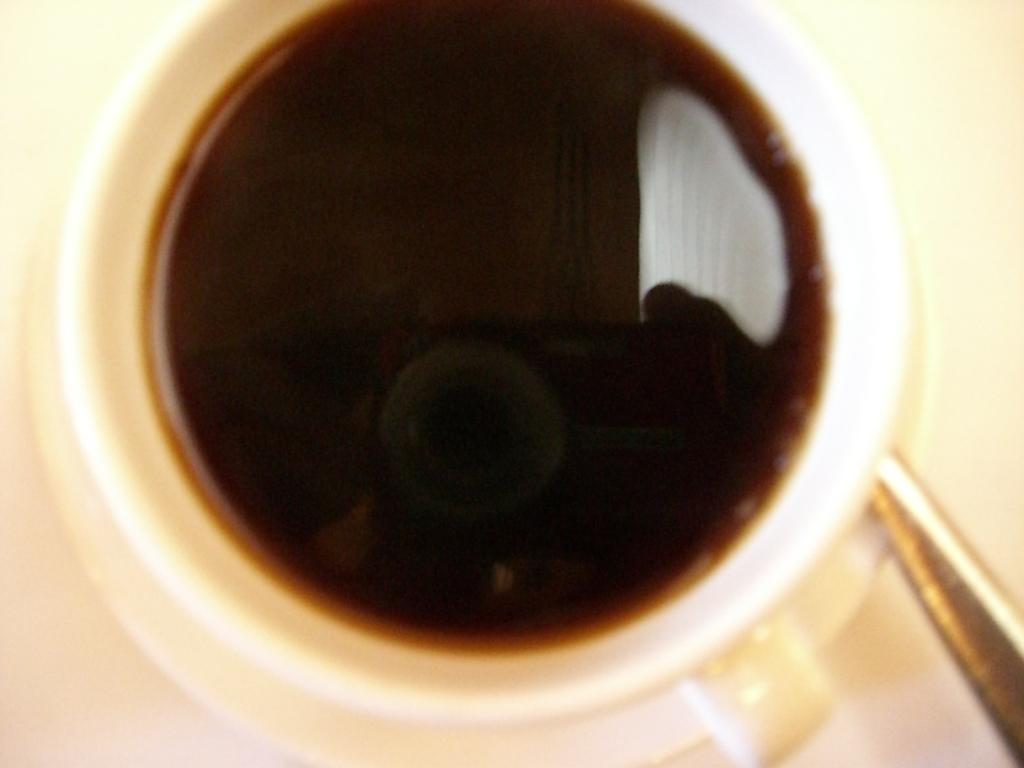What object is present in the image that can hold a beverage? There is a cup in the image. What type of beverage is in the cup? The cup contains coffee. What type of badge is visible on the cup in the image? There is no badge present on the cup in the image. How many times does the coffee twist in the cup? The coffee does not twist in the cup; it is a liquid and remains in a stationary state. 